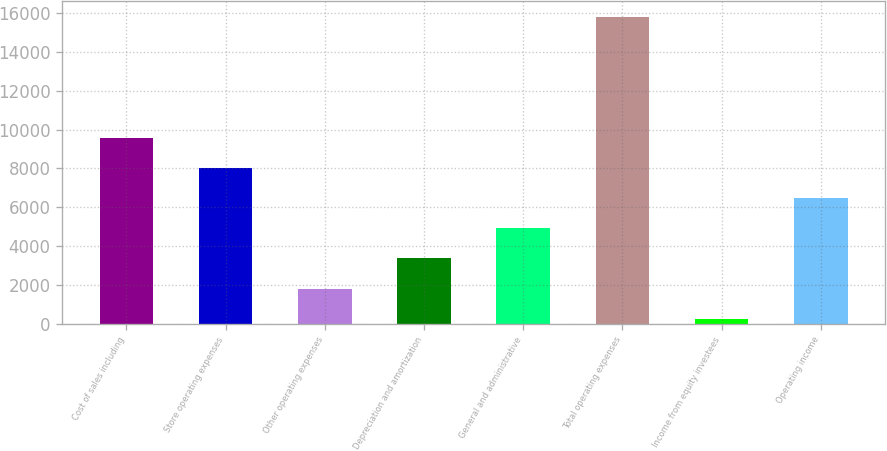<chart> <loc_0><loc_0><loc_500><loc_500><bar_chart><fcel>Cost of sales including<fcel>Store operating expenses<fcel>Other operating expenses<fcel>Depreciation and amortization<fcel>General and administrative<fcel>Total operating expenses<fcel>Income from equity investees<fcel>Operating income<nl><fcel>9586.92<fcel>8030.75<fcel>1806.07<fcel>3362.24<fcel>4918.41<fcel>15811.6<fcel>249.9<fcel>6474.58<nl></chart> 